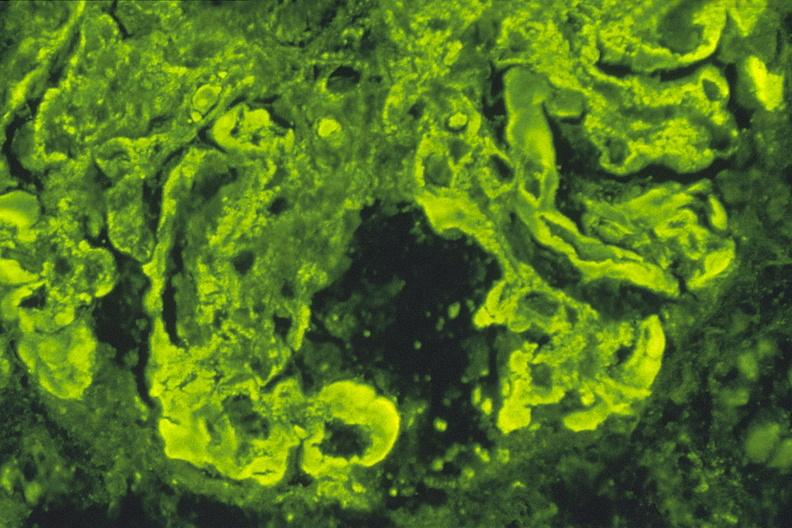s this person present?
Answer the question using a single word or phrase. No 